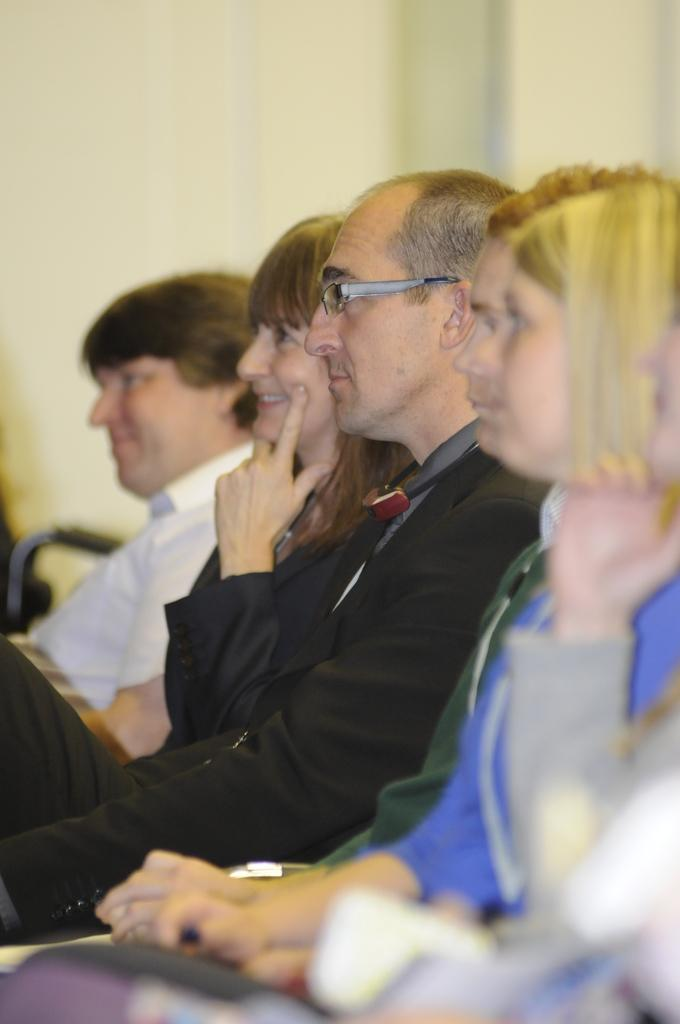What can be seen in the image? There is a group of people in the image. How are the people dressed? The people are wearing different color dresses. Can you identify any accessories worn by the people? One person is wearing glasses (specs). What is visible in the background of the image? There is a wall in the background of the image. What type of horse can be seen in the image? There is no horse present in the image; it features a group of people wearing different color dresses and one person wearing glasses. 